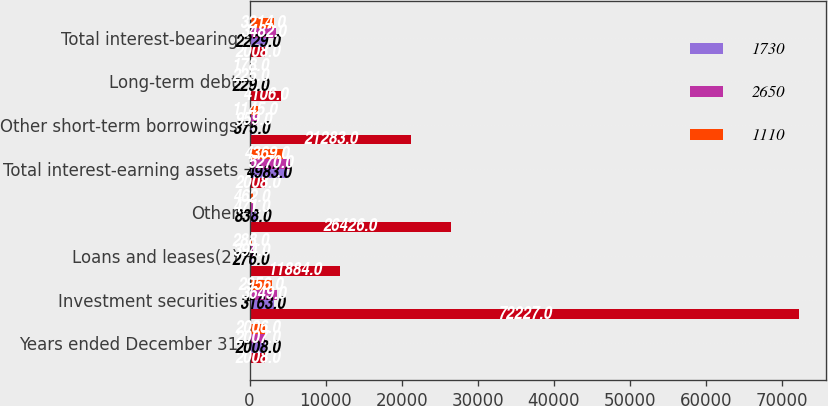Convert chart. <chart><loc_0><loc_0><loc_500><loc_500><stacked_bar_chart><ecel><fcel>Years ended December 31<fcel>Investment securities<fcel>Loans and leases(2)<fcel>Other<fcel>Total interest-earning assets<fcel>Other short-term borrowings<fcel>Long-term debt<fcel>Total interest-bearing<nl><fcel>nan<fcel>2008<fcel>72227<fcel>11884<fcel>26426<fcel>2008<fcel>21283<fcel>4106<fcel>2008<nl><fcel>1730<fcel>2008<fcel>3163<fcel>276<fcel>838<fcel>4983<fcel>375<fcel>229<fcel>2229<nl><fcel>2650<fcel>2007<fcel>3649<fcel>394<fcel>471<fcel>5270<fcel>959<fcel>225<fcel>3482<nl><fcel>1110<fcel>2006<fcel>2956<fcel>288<fcel>462<fcel>4369<fcel>1145<fcel>178<fcel>3214<nl></chart> 